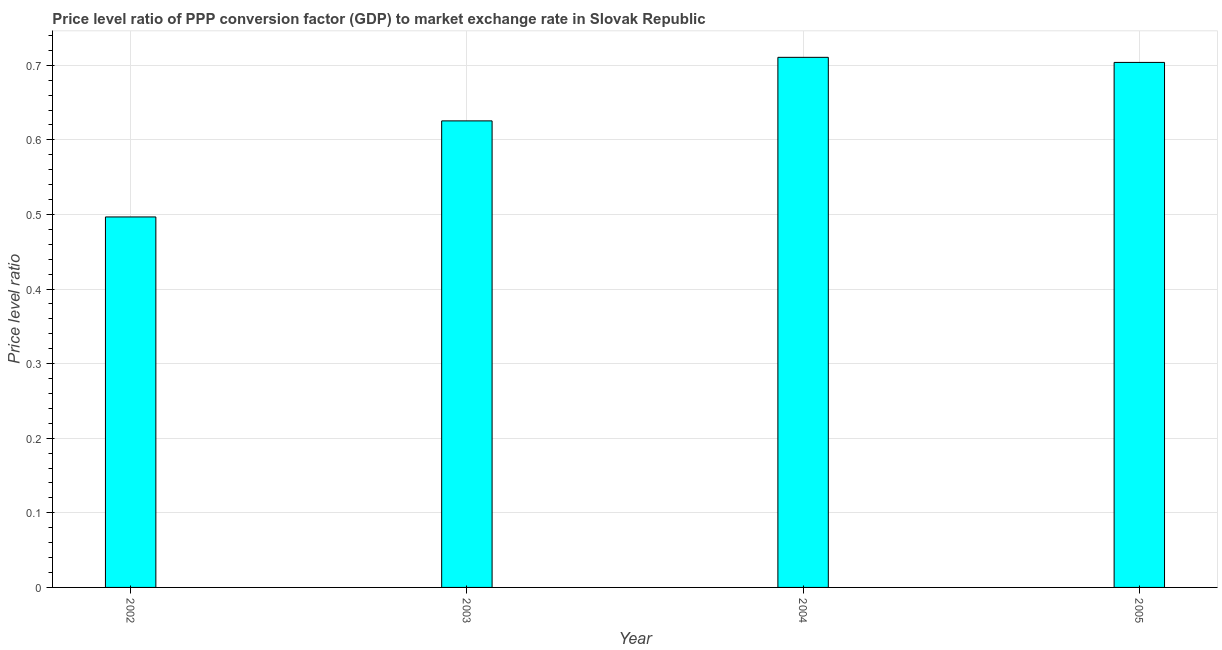Does the graph contain grids?
Make the answer very short. Yes. What is the title of the graph?
Provide a short and direct response. Price level ratio of PPP conversion factor (GDP) to market exchange rate in Slovak Republic. What is the label or title of the X-axis?
Provide a short and direct response. Year. What is the label or title of the Y-axis?
Your answer should be very brief. Price level ratio. What is the price level ratio in 2002?
Make the answer very short. 0.5. Across all years, what is the maximum price level ratio?
Offer a very short reply. 0.71. Across all years, what is the minimum price level ratio?
Offer a very short reply. 0.5. In which year was the price level ratio maximum?
Offer a terse response. 2004. What is the sum of the price level ratio?
Your answer should be very brief. 2.54. What is the difference between the price level ratio in 2002 and 2004?
Offer a very short reply. -0.21. What is the average price level ratio per year?
Your response must be concise. 0.63. What is the median price level ratio?
Give a very brief answer. 0.66. In how many years, is the price level ratio greater than 0.16 ?
Make the answer very short. 4. What is the ratio of the price level ratio in 2002 to that in 2003?
Keep it short and to the point. 0.79. Is the price level ratio in 2002 less than that in 2004?
Provide a succinct answer. Yes. What is the difference between the highest and the second highest price level ratio?
Offer a very short reply. 0.01. What is the difference between the highest and the lowest price level ratio?
Ensure brevity in your answer.  0.21. How many bars are there?
Your answer should be compact. 4. Are the values on the major ticks of Y-axis written in scientific E-notation?
Provide a short and direct response. No. What is the Price level ratio in 2002?
Your response must be concise. 0.5. What is the Price level ratio in 2003?
Give a very brief answer. 0.63. What is the Price level ratio in 2004?
Make the answer very short. 0.71. What is the Price level ratio in 2005?
Offer a terse response. 0.7. What is the difference between the Price level ratio in 2002 and 2003?
Give a very brief answer. -0.13. What is the difference between the Price level ratio in 2002 and 2004?
Offer a very short reply. -0.21. What is the difference between the Price level ratio in 2002 and 2005?
Keep it short and to the point. -0.21. What is the difference between the Price level ratio in 2003 and 2004?
Your answer should be compact. -0.09. What is the difference between the Price level ratio in 2003 and 2005?
Your response must be concise. -0.08. What is the difference between the Price level ratio in 2004 and 2005?
Provide a succinct answer. 0.01. What is the ratio of the Price level ratio in 2002 to that in 2003?
Ensure brevity in your answer.  0.79. What is the ratio of the Price level ratio in 2002 to that in 2004?
Keep it short and to the point. 0.7. What is the ratio of the Price level ratio in 2002 to that in 2005?
Keep it short and to the point. 0.71. What is the ratio of the Price level ratio in 2003 to that in 2005?
Keep it short and to the point. 0.89. What is the ratio of the Price level ratio in 2004 to that in 2005?
Provide a short and direct response. 1.01. 